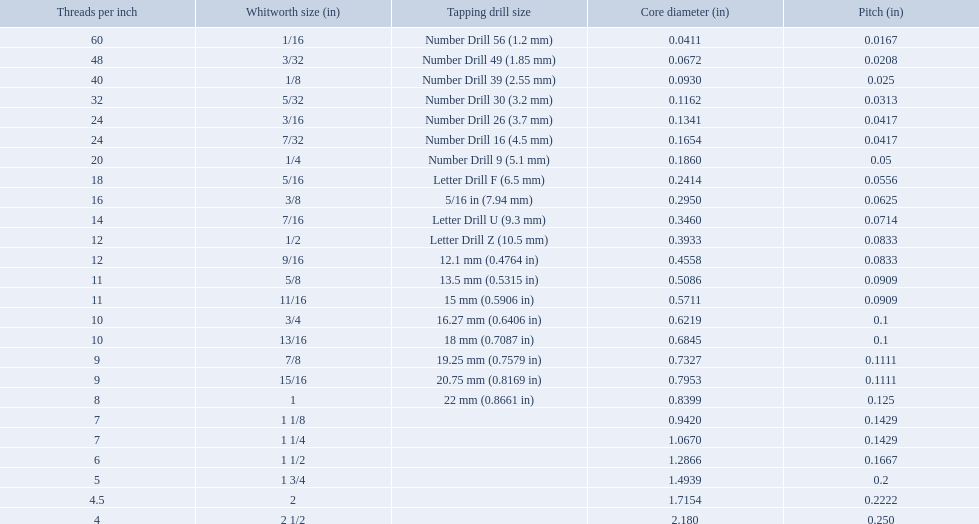What is the core diameter for the number drill 26? 0.1341. What is the whitworth size (in) for this core diameter? 3/16. 